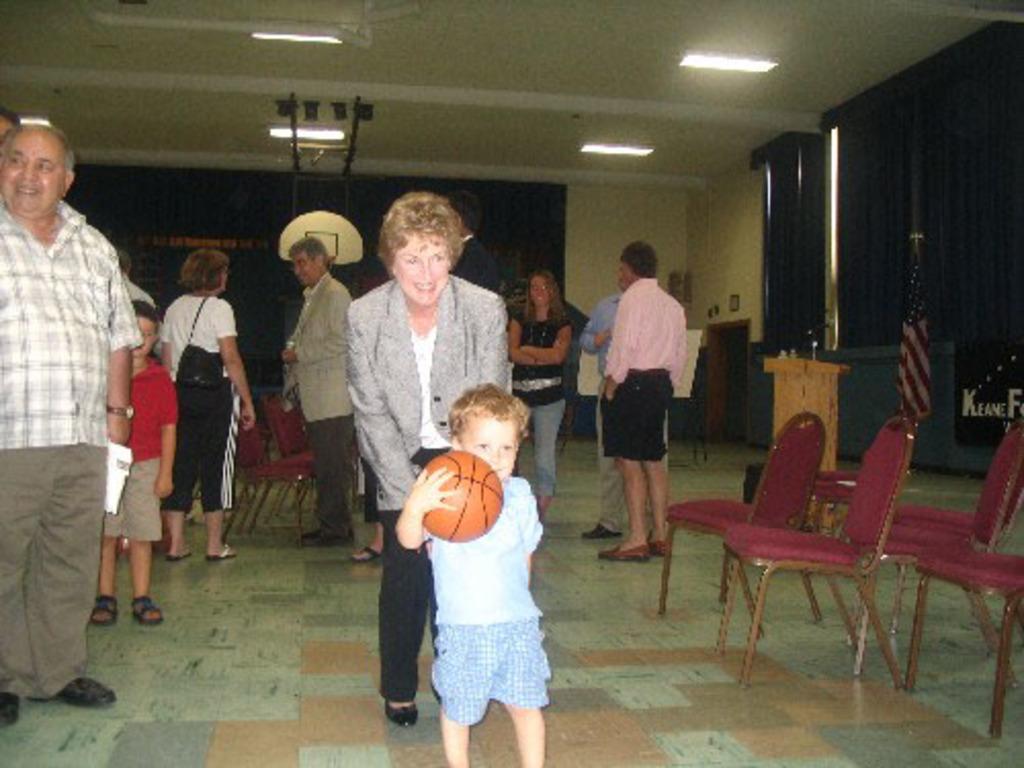How would you summarize this image in a sentence or two? In this image there is one boy standing at bottom of the image is holding a ball which is in red color. There is one women standing behind him is wearing black color shoes and black color pant and there are three chairs at right side of this image and there are some windows at right side of this image. There are three persons standing at right side of this image. one person is wearing white color shirt and black color short and there are some persons standing at left side of this image. there are some lights arranged at top of the image. 